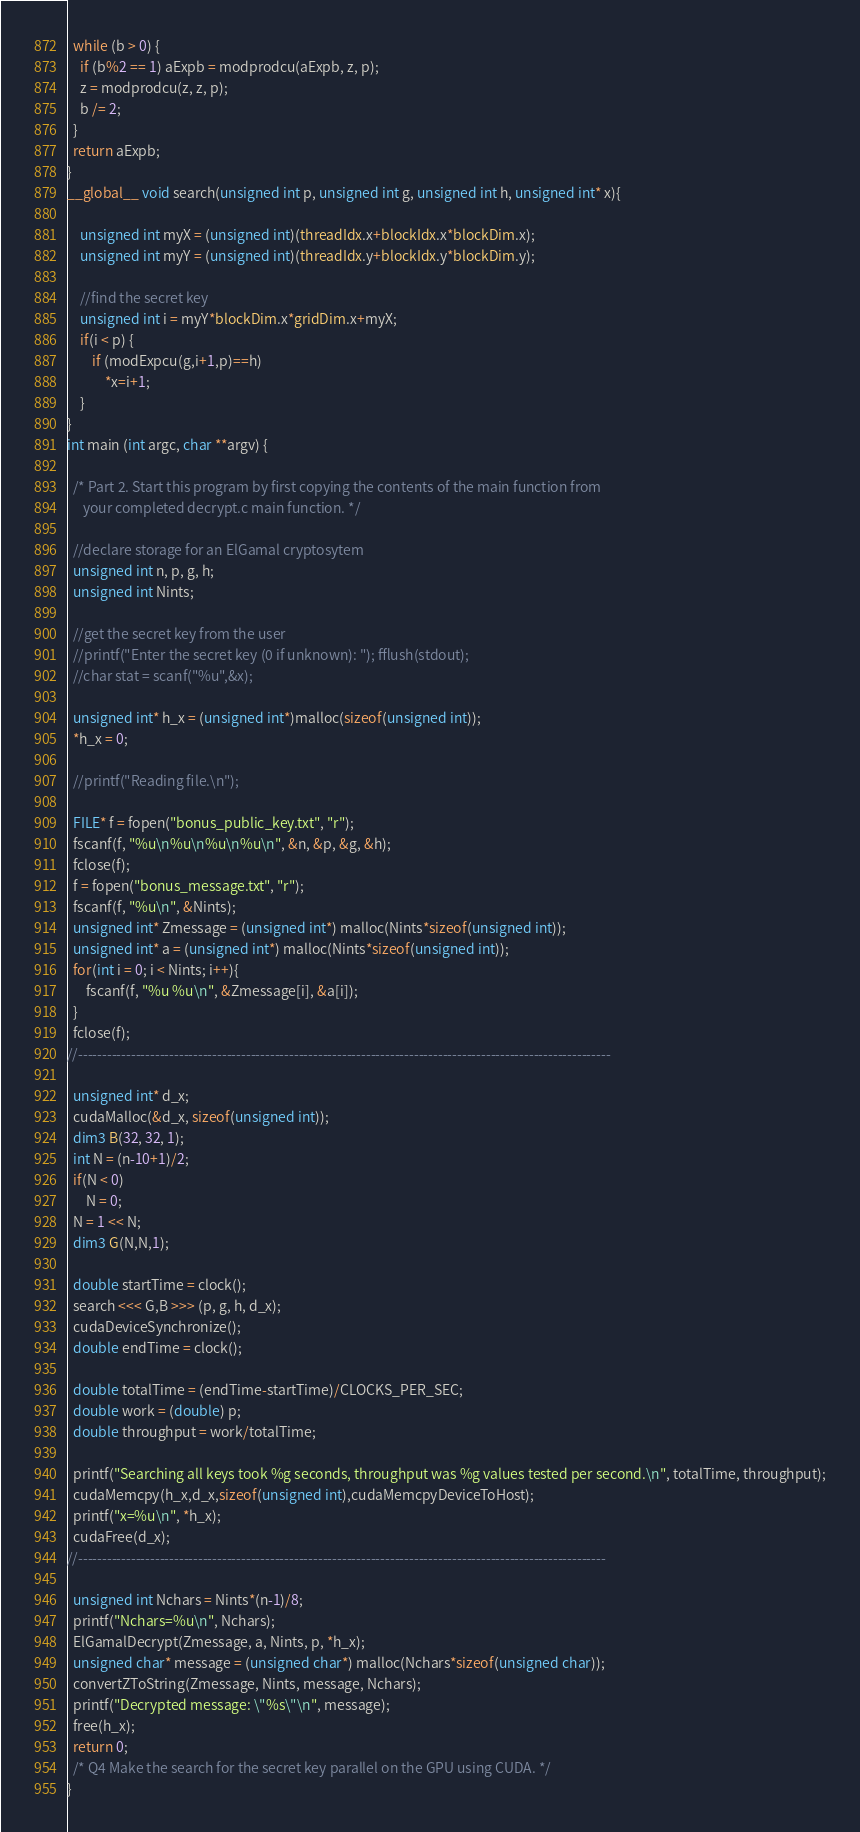Convert code to text. <code><loc_0><loc_0><loc_500><loc_500><_Cuda_>
  while (b > 0) {
    if (b%2 == 1) aExpb = modprodcu(aExpb, z, p);
    z = modprodcu(z, z, p);
    b /= 2;
  }
  return aExpb;
}
__global__ void search(unsigned int p, unsigned int g, unsigned int h, unsigned int* x){

    unsigned int myX = (unsigned int)(threadIdx.x+blockIdx.x*blockDim.x);
	unsigned int myY = (unsigned int)(threadIdx.y+blockIdx.y*blockDim.y);

	//find the secret key
	unsigned int i = myY*blockDim.x*gridDim.x+myX;
	if(i < p) {
    	if (modExpcu(g,i+1,p)==h)
       		*x=i+1;
	}
}
int main (int argc, char **argv) {

  /* Part 2. Start this program by first copying the contents of the main function from 
     your completed decrypt.c main function. */

  //declare storage for an ElGamal cryptosytem
  unsigned int n, p, g, h;
  unsigned int Nints;

  //get the secret key from the user
  //printf("Enter the secret key (0 if unknown): "); fflush(stdout);
  //char stat = scanf("%u",&x);

  unsigned int* h_x = (unsigned int*)malloc(sizeof(unsigned int));
  *h_x = 0;

  //printf("Reading file.\n");

  FILE* f = fopen("bonus_public_key.txt", "r");
  fscanf(f, "%u\n%u\n%u\n%u\n", &n, &p, &g, &h);
  fclose(f);
  f = fopen("bonus_message.txt", "r");
  fscanf(f, "%u\n", &Nints);
  unsigned int* Zmessage = (unsigned int*) malloc(Nints*sizeof(unsigned int));
  unsigned int* a = (unsigned int*) malloc(Nints*sizeof(unsigned int));
  for(int i = 0; i < Nints; i++){
	  fscanf(f, "%u %u\n", &Zmessage[i], &a[i]);
  }
  fclose(f);
//---------------------------------------------------------------------------------------------------------------
    
  unsigned int* d_x;
  cudaMalloc(&d_x, sizeof(unsigned int));
  dim3 B(32, 32, 1);
  int N = (n-10+1)/2;
  if(N < 0)
	  N = 0;
  N = 1 << N;
  dim3 G(N,N,1);

  double startTime = clock();
  search <<< G,B >>> (p, g, h, d_x);
  cudaDeviceSynchronize();
  double endTime = clock();

  double totalTime = (endTime-startTime)/CLOCKS_PER_SEC;
  double work = (double) p;
  double throughput = work/totalTime;

  printf("Searching all keys took %g seconds, throughput was %g values tested per second.\n", totalTime, throughput);
  cudaMemcpy(h_x,d_x,sizeof(unsigned int),cudaMemcpyDeviceToHost);
  printf("x=%u\n", *h_x);
  cudaFree(d_x);
//--------------------------------------------------------------------------------------------------------------

  unsigned int Nchars = Nints*(n-1)/8;
  printf("Nchars=%u\n", Nchars);
  ElGamalDecrypt(Zmessage, a, Nints, p, *h_x);
  unsigned char* message = (unsigned char*) malloc(Nchars*sizeof(unsigned char));
  convertZToString(Zmessage, Nints, message, Nchars);
  printf("Decrypted message: \"%s\"\n", message);
  free(h_x);
  return 0;
  /* Q4 Make the search for the secret key parallel on the GPU using CUDA. */
}
</code> 